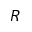Convert formula to latex. <formula><loc_0><loc_0><loc_500><loc_500>R</formula> 